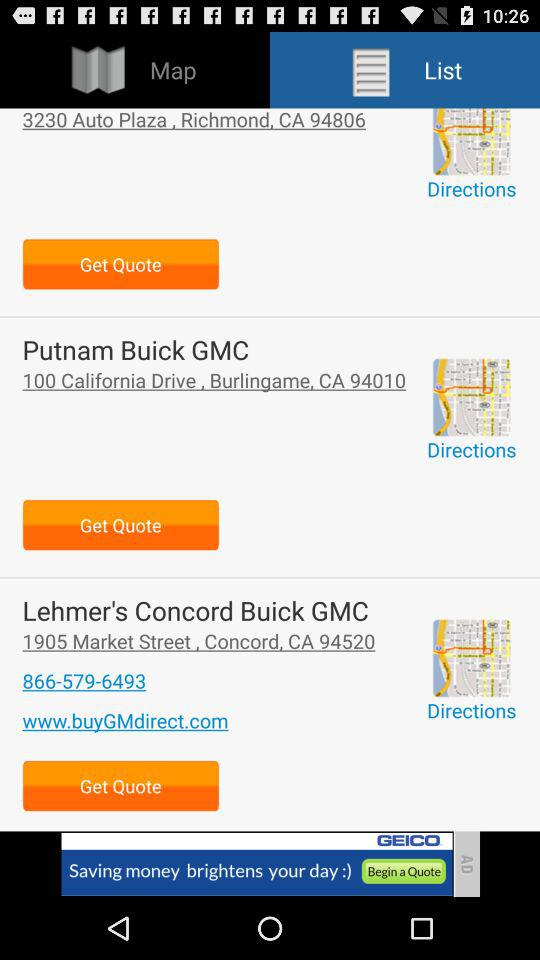What is the contact number for "Lehmer's Concord Buick GMC"? The contact number for "Lehmer's Concord Buick GMC" is 866-579-6493. 